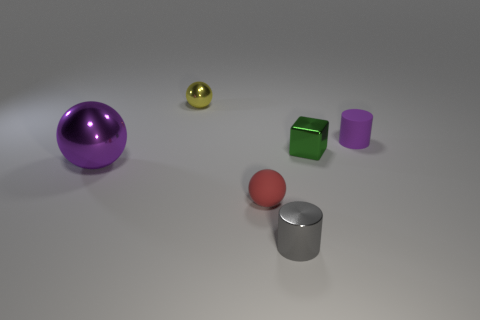Are there any other things that are the same size as the purple ball?
Your answer should be compact. No. Is there anything else that has the same shape as the green shiny object?
Provide a succinct answer. No. What is the size of the metallic sphere that is behind the purple thing that is to the right of the tiny green shiny cube in front of the small yellow shiny ball?
Your response must be concise. Small. Are the purple sphere and the small sphere that is behind the matte cylinder made of the same material?
Your answer should be compact. Yes. Is the shape of the gray object the same as the purple rubber object?
Your answer should be compact. Yes. What number of other things are there of the same material as the green object
Your answer should be compact. 3. How many other tiny yellow things have the same shape as the small yellow object?
Provide a succinct answer. 0. There is a small object that is both left of the small gray object and behind the large shiny sphere; what is its color?
Ensure brevity in your answer.  Yellow. What number of small yellow objects are there?
Your response must be concise. 1. Is the purple rubber cylinder the same size as the red thing?
Give a very brief answer. Yes. 